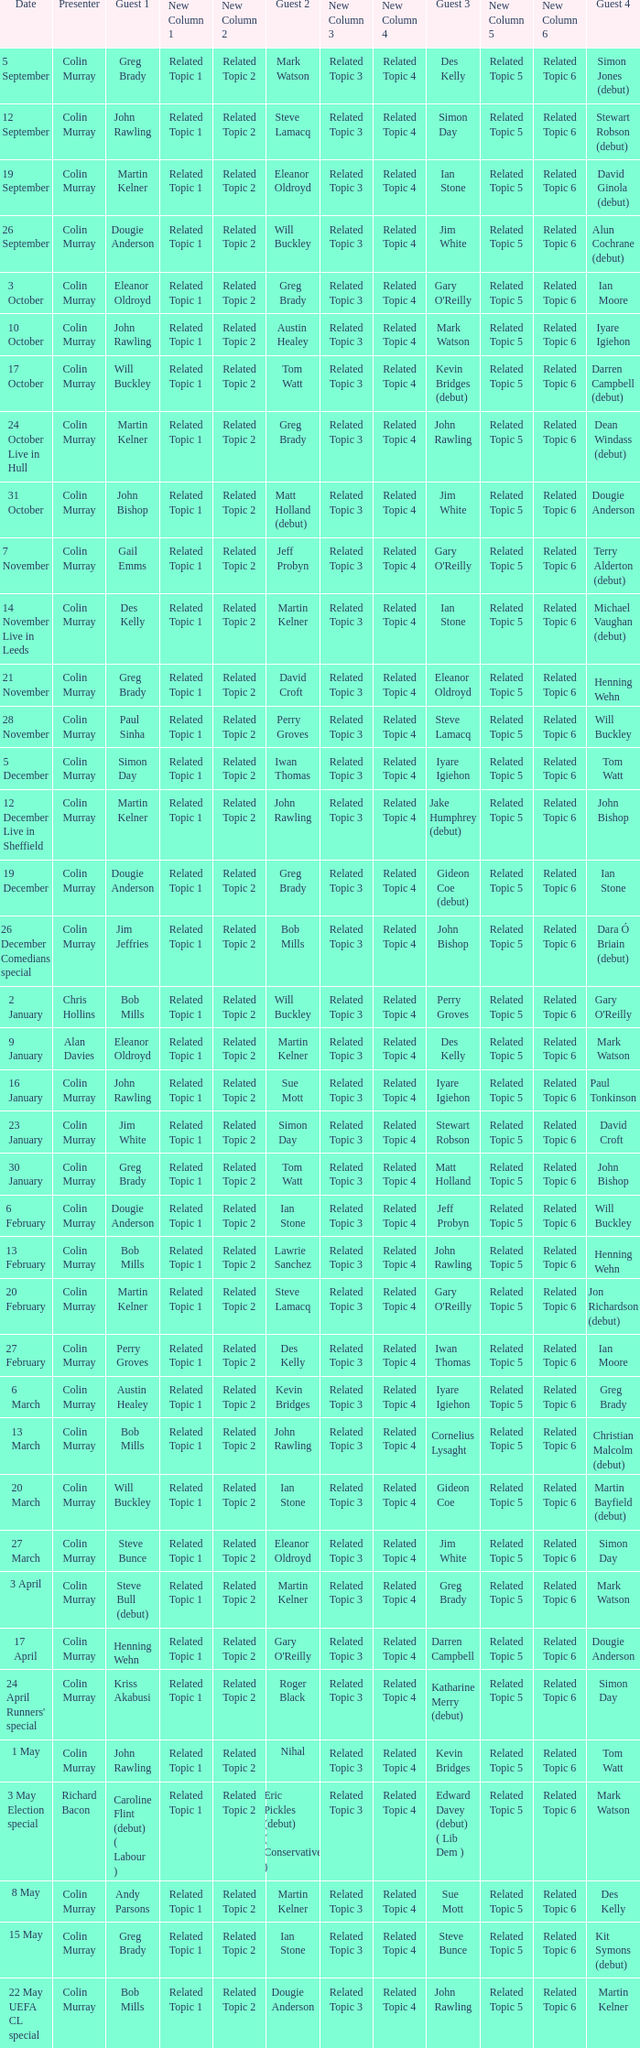On episodes where guest 1 is Jim White, who was guest 3? Stewart Robson. 